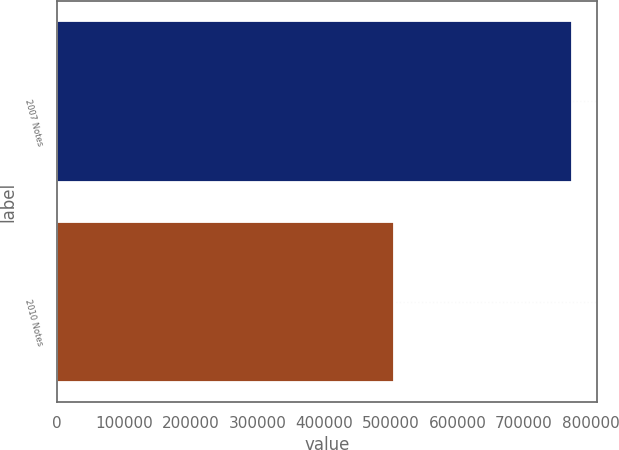Convert chart to OTSL. <chart><loc_0><loc_0><loc_500><loc_500><bar_chart><fcel>2007 Notes<fcel>2010 Notes<nl><fcel>771600<fcel>505600<nl></chart> 